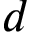<formula> <loc_0><loc_0><loc_500><loc_500>d</formula> 